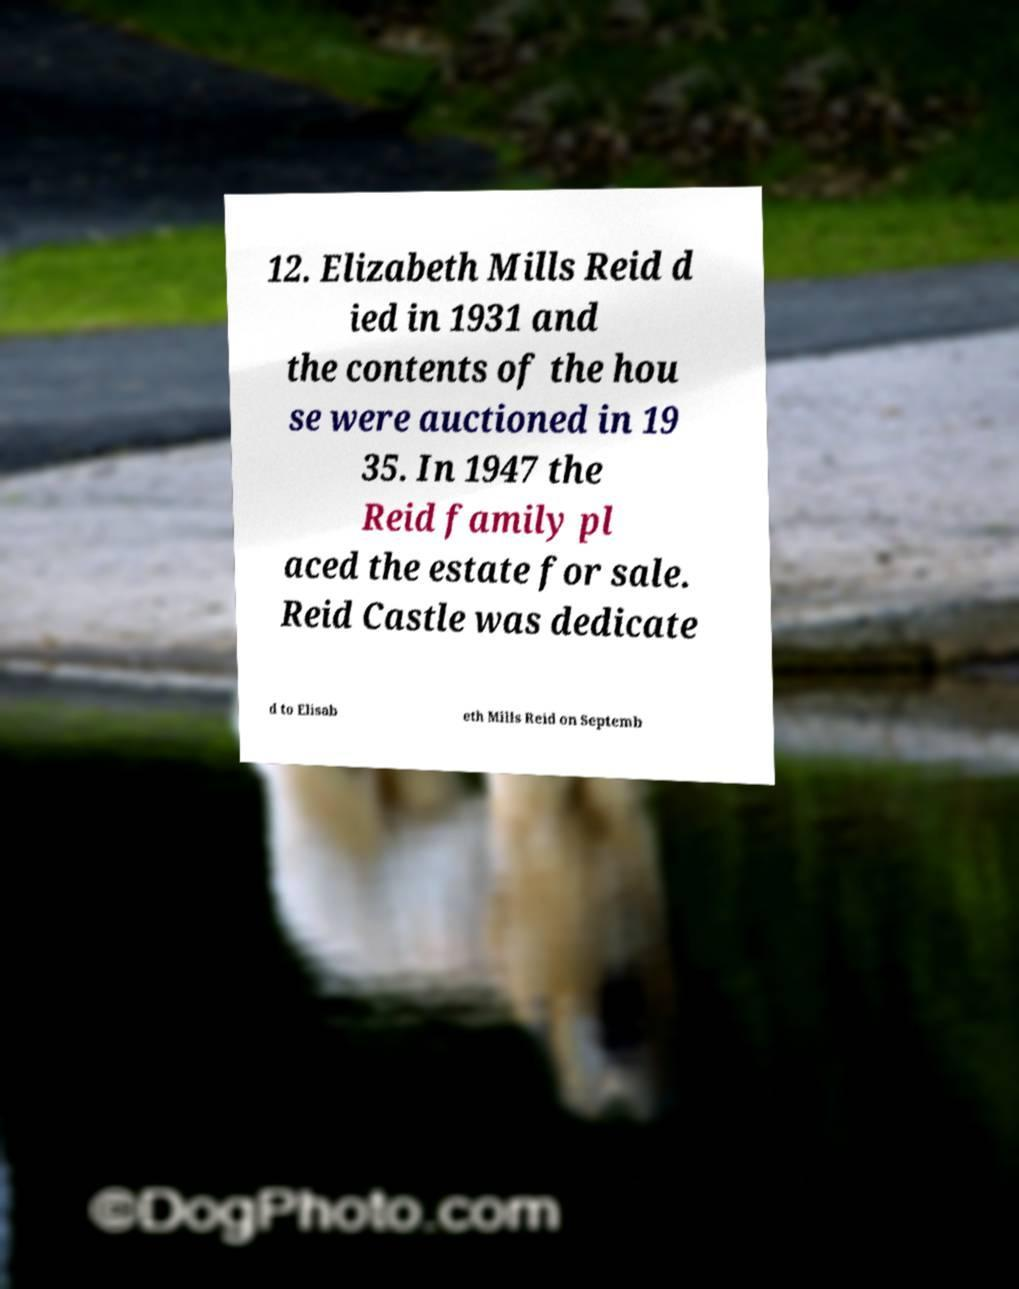Can you accurately transcribe the text from the provided image for me? 12. Elizabeth Mills Reid d ied in 1931 and the contents of the hou se were auctioned in 19 35. In 1947 the Reid family pl aced the estate for sale. Reid Castle was dedicate d to Elisab eth Mills Reid on Septemb 